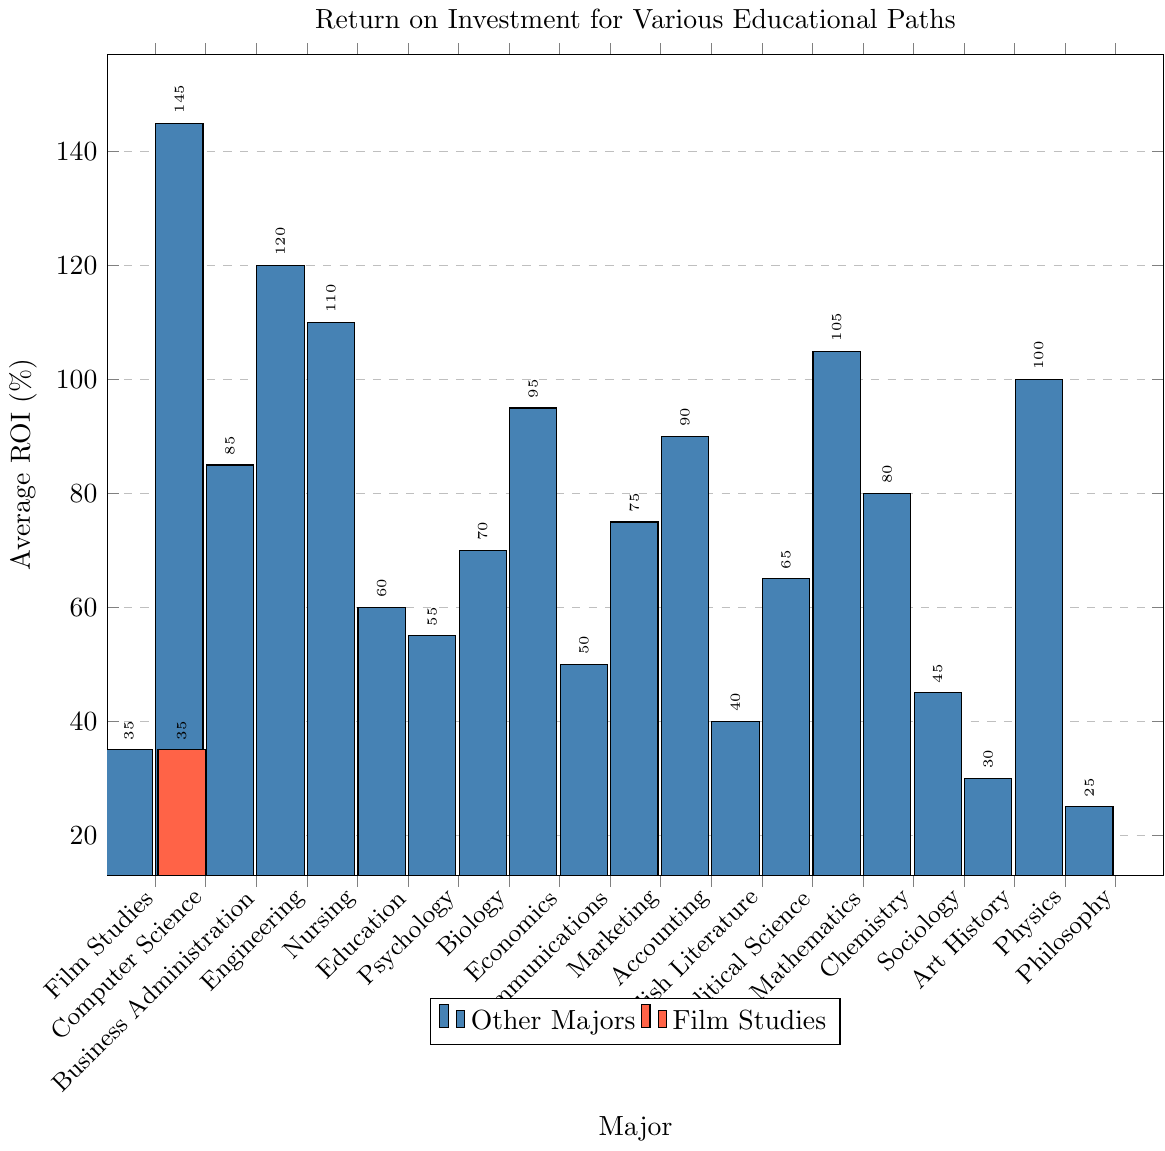What is the average ROI for majors in the STEM fields (Computer Science, Engineering, Nursing, Mathematics, Chemistry, Physics)? Identify the ROI values for each of the STEM fields: Computer Science (145%), Engineering (120%), Nursing (110%), Mathematics (105%), Chemistry (80%), Physics (100%). Sum these values: 145 + 120 + 110 + 105 + 80 + 100 = 660, and then divide by the number of fields (6) to find the average: 660 / 6 = 110
Answer: 110 How does the ROI of Film Studies compare to the highest ROI major? Identify the ROIs for all majors and note that the highest ROI is for Computer Science at 145%. Compare this to the ROI of Film Studies which is 35%.
Answer: The ROI of Film Studies is 110% less than the highest ROI major, Computer Science Which major has the lowest ROI, and what is its value? Scan the bar chart and identify that Philosophy has the lowest ROI among all the majors, which is 25%.
Answer: Philosophy with 25% ROI What's the difference in ROI between the highest ROI major and the lowest ROI major? The highest ROI (Computer Science) is 145%, and the lowest (Philosophy) is 25%. Calculate the difference: 145 - 25 = 120
Answer: 120 How many majors have a higher ROI than Film Studies? Identify the majors that have a higher ROI than Film Studies' 35%: Computer Science (145%), Business Administration (85%), Engineering (120%), Nursing (110%), Education (60%), Psychology (55%), Biology (70%), Economics (95%), Communications (50%), Marketing (75%), Accounting (90%), English Literature (40%), Political Science (65%), Mathematics (105%), Chemistry (80%), Sociology (45%), Physics (100%). Count these majors: 18
Answer: 18 Excluding Film Studies, what is the average ROI of non-STEM majors (Business Administration, Education, Psychology, Biology, Economics, Communications, Marketing, Accounting, English Literature, Political Science, Sociology, Art History, Philosophy)? Calculate the average ROI for these 13 non-STEM majors. Sum their ROI values: 85 + 60 + 55 + 70 + 95 + 50 + 75 + 90 + 40 + 65 + 45 + 30 + 25 = 785, and divide by 13: 785 / 13 ≈ 60.38
Answer: 60.38 Between Film Studies and Nursing, which major has a higher ROI and by how much? Compare the ROIs of Film Studies (35%) and Nursing (110%). Calculate the difference: 110 - 35 = 75
Answer: Nursing by 75 Which major has an ROI closest to that of Film Studies? Scan the bar chart and identify the major closest to Film Studies' 35%. English Literature has an ROI of 40%, which is the closest.
Answer: English Literature How many majors have an ROI that falls between 50% and 120%? Check the ROIs of each major and count those falling in the range: Business Administration (85%), Engineering (120%), Nursing (110%), Education (60%), Psychology (55%), Biology (70%), Economics (95%), Communications (50%), Marketing (75%), Accounting (90%), Political Science (65%), Mathematics (105%), Chemistry (80%), Sociology (45%). There are 13 majors in this range.
Answer: 13 How does the ROI of Art History compare to that of Sociology? Compare the ROI values: Art History (30%) and Sociology (45%). Sociology's ROI is higher by 15%.
Answer: Sociology by 15 Which major has a higher ROI: Art History or English Literature, and by how much? Compare the ROIs: Art History (30%) and English Literature (40%). Calculate the difference: 40 - 30 = 10
Answer: English Literature by 10 